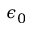Convert formula to latex. <formula><loc_0><loc_0><loc_500><loc_500>\epsilon _ { 0 }</formula> 